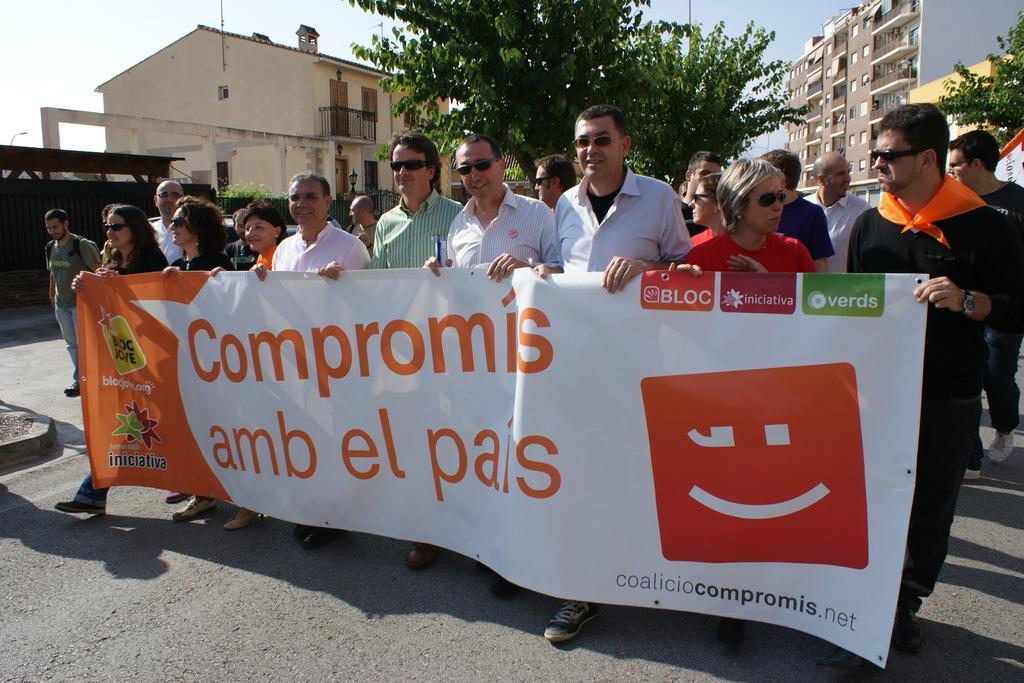Could you give a brief overview of what you see in this image? In this image I can see the ground and number of persons are standing on the ground and holding the banner which is orange and white in color. In the background I can see few trees, few buildings and the sky. 